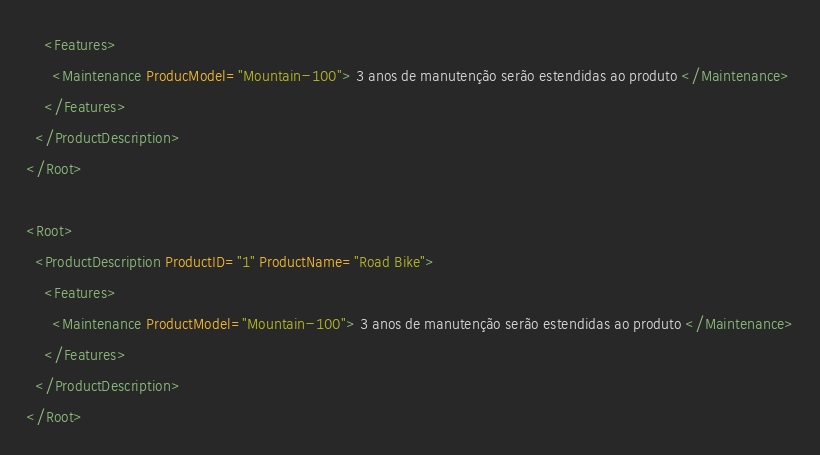<code> <loc_0><loc_0><loc_500><loc_500><_XML_>    <Features>
      <Maintenance ProducModel="Mountain-100"> 3 anos de manutenção serão estendidas ao produto </Maintenance>
    </Features>    
  </ProductDescription>
</Root>

<Root>
  <ProductDescription ProductID="1" ProductName="Road Bike">
    <Features>
      <Maintenance ProductModel="Mountain-100"> 3 anos de manutenção serão estendidas ao produto </Maintenance>
    </Features>    
  </ProductDescription>
</Root>


</code> 